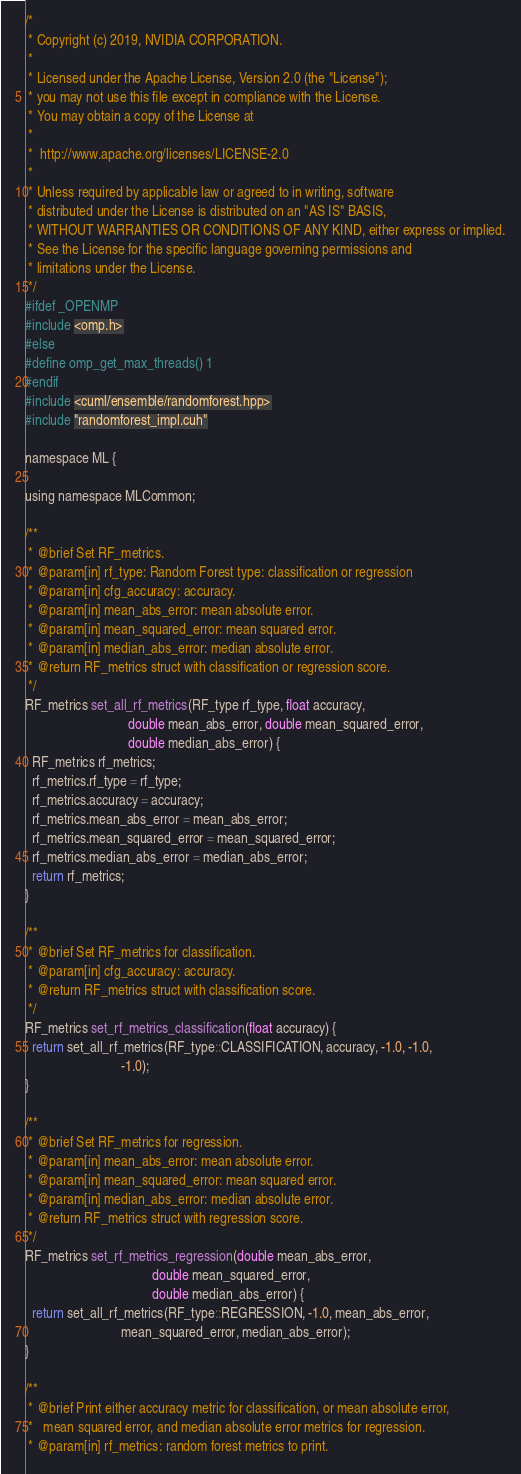<code> <loc_0><loc_0><loc_500><loc_500><_Cuda_>/*
 * Copyright (c) 2019, NVIDIA CORPORATION.
 *
 * Licensed under the Apache License, Version 2.0 (the "License");
 * you may not use this file except in compliance with the License.
 * You may obtain a copy of the License at
 *
 *  http://www.apache.org/licenses/LICENSE-2.0
 *
 * Unless required by applicable law or agreed to in writing, software
 * distributed under the License is distributed on an "AS IS" BASIS,
 * WITHOUT WARRANTIES OR CONDITIONS OF ANY KIND, either express or implied.
 * See the License for the specific language governing permissions and
 * limitations under the License.
 */
#ifdef _OPENMP
#include <omp.h>
#else
#define omp_get_max_threads() 1
#endif
#include <cuml/ensemble/randomforest.hpp>
#include "randomforest_impl.cuh"

namespace ML {

using namespace MLCommon;

/**
 * @brief Set RF_metrics.
 * @param[in] rf_type: Random Forest type: classification or regression
 * @param[in] cfg_accuracy: accuracy.
 * @param[in] mean_abs_error: mean absolute error.
 * @param[in] mean_squared_error: mean squared error.
 * @param[in] median_abs_error: median absolute error.
 * @return RF_metrics struct with classification or regression score.
 */
RF_metrics set_all_rf_metrics(RF_type rf_type, float accuracy,
                              double mean_abs_error, double mean_squared_error,
                              double median_abs_error) {
  RF_metrics rf_metrics;
  rf_metrics.rf_type = rf_type;
  rf_metrics.accuracy = accuracy;
  rf_metrics.mean_abs_error = mean_abs_error;
  rf_metrics.mean_squared_error = mean_squared_error;
  rf_metrics.median_abs_error = median_abs_error;
  return rf_metrics;
}

/**
 * @brief Set RF_metrics for classification.
 * @param[in] cfg_accuracy: accuracy.
 * @return RF_metrics struct with classification score.
 */
RF_metrics set_rf_metrics_classification(float accuracy) {
  return set_all_rf_metrics(RF_type::CLASSIFICATION, accuracy, -1.0, -1.0,
                            -1.0);
}

/**
 * @brief Set RF_metrics for regression.
 * @param[in] mean_abs_error: mean absolute error.
 * @param[in] mean_squared_error: mean squared error.
 * @param[in] median_abs_error: median absolute error.
 * @return RF_metrics struct with regression score.
 */
RF_metrics set_rf_metrics_regression(double mean_abs_error,
                                     double mean_squared_error,
                                     double median_abs_error) {
  return set_all_rf_metrics(RF_type::REGRESSION, -1.0, mean_abs_error,
                            mean_squared_error, median_abs_error);
}

/**
 * @brief Print either accuracy metric for classification, or mean absolute error,
 *   mean squared error, and median absolute error metrics for regression.
 * @param[in] rf_metrics: random forest metrics to print.</code> 